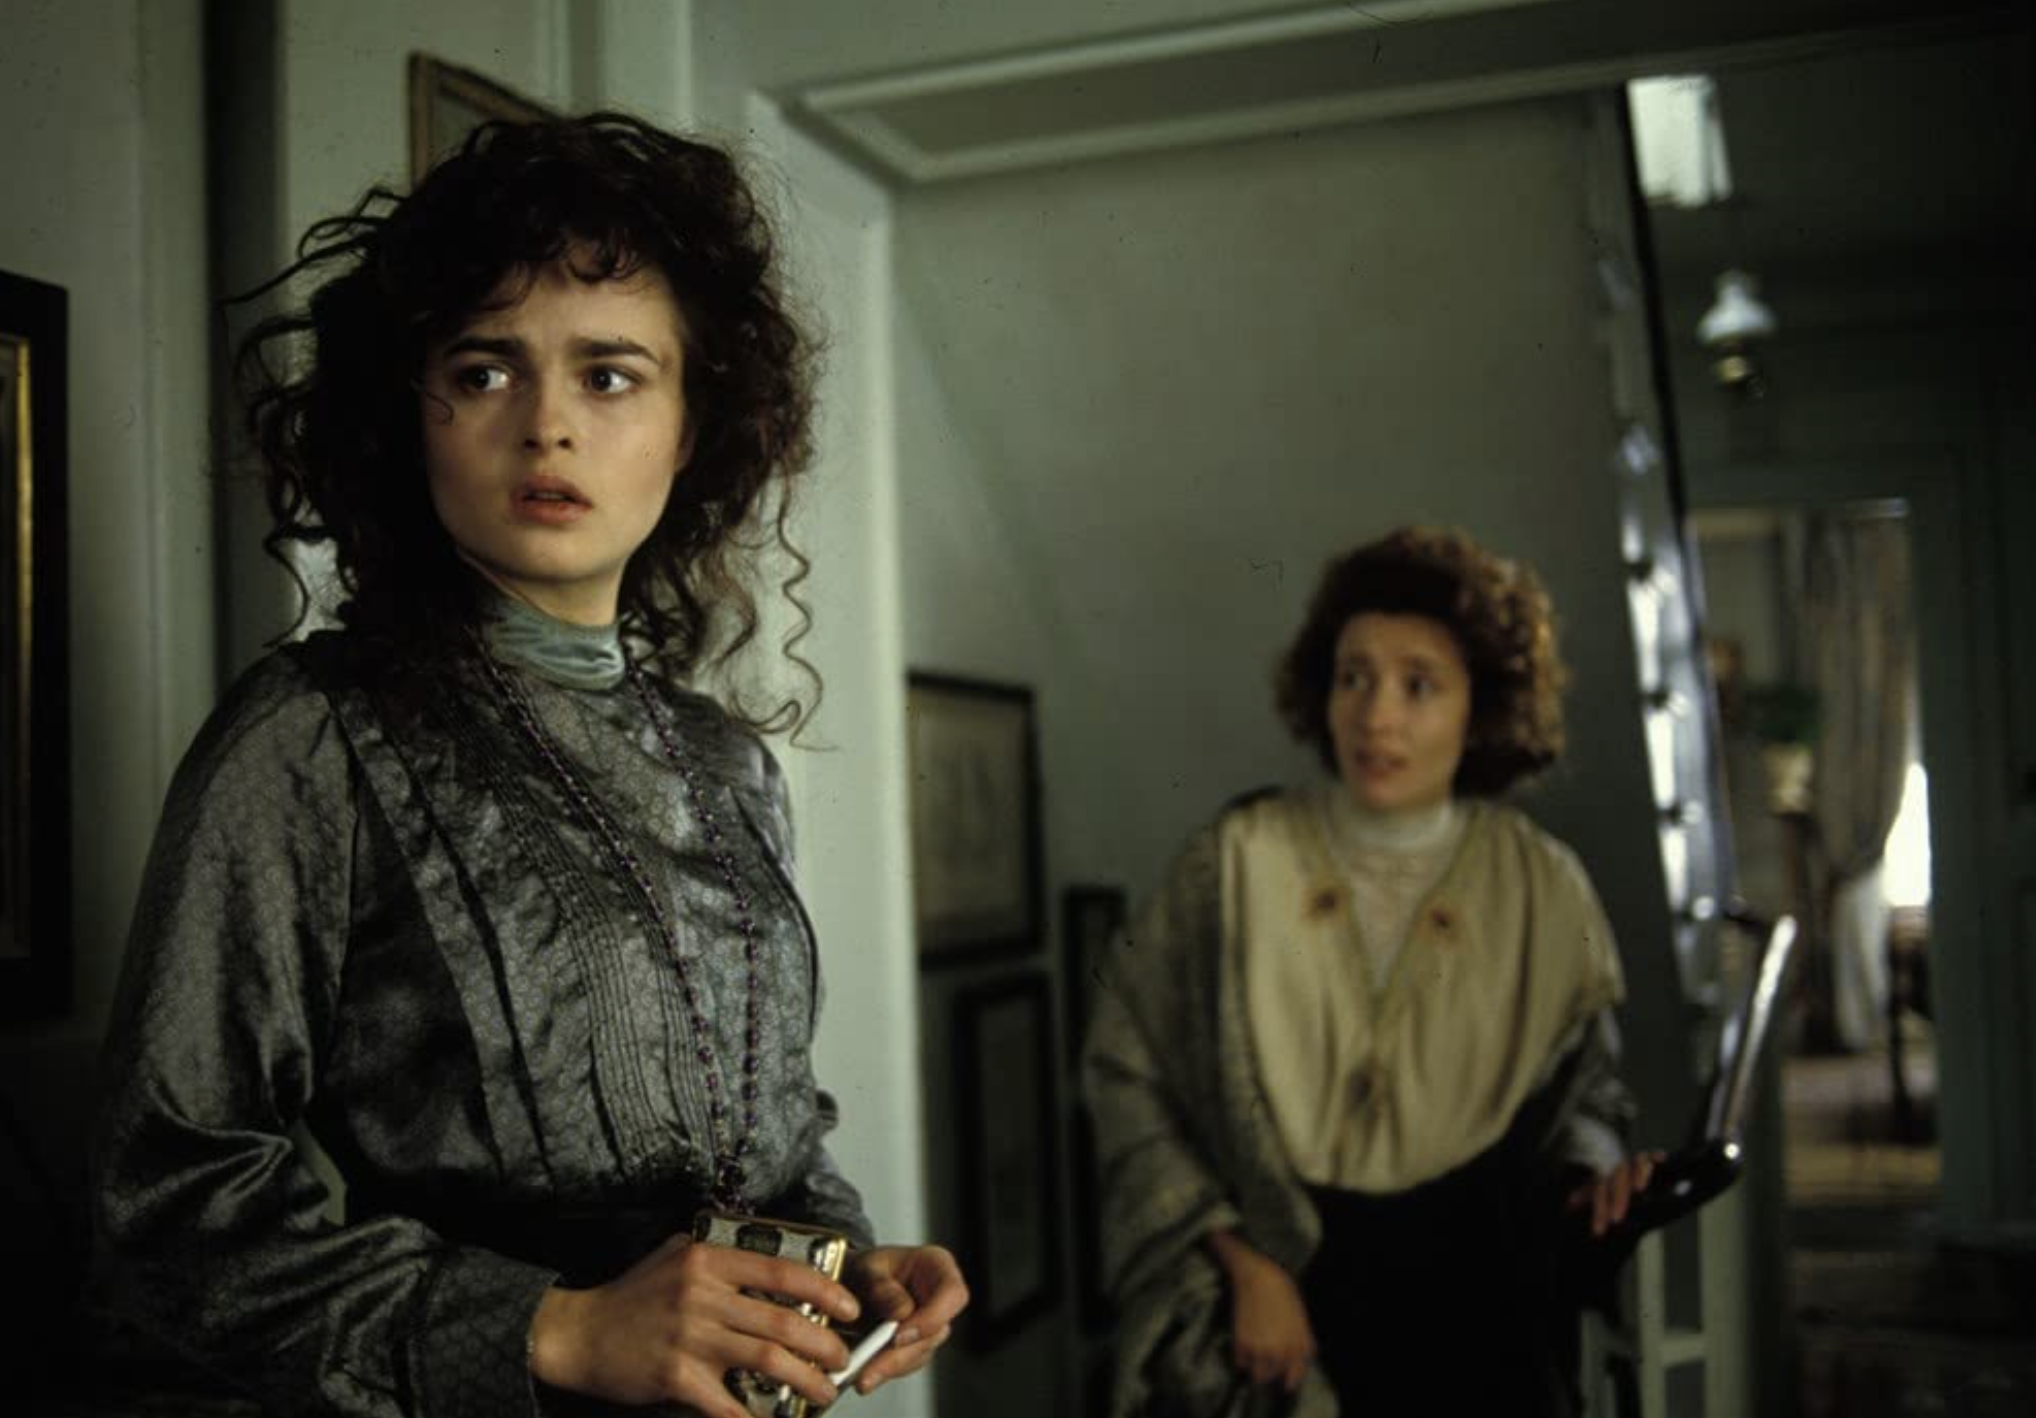What are the key elements in this picture?
 In this image, we see a scene from the movie "A Room with a View". The central figure is the character Lucy Honeychurch, portrayed by Helena Bonham Carter. Lucy is standing in the foreground of the image, her gaze directed off to the side, a worried expression on her face. She is dressed in a gray dress with a high collar, and her hair is styled in loose curls. Behind Lucy, in the doorway of the room, stands her cousin Charlotte Bartlett, played by Maggie Smith, holding a parasol. The room itself has light blue walls and features a window on the left side. The overall atmosphere suggests a moment of tension or concern. 